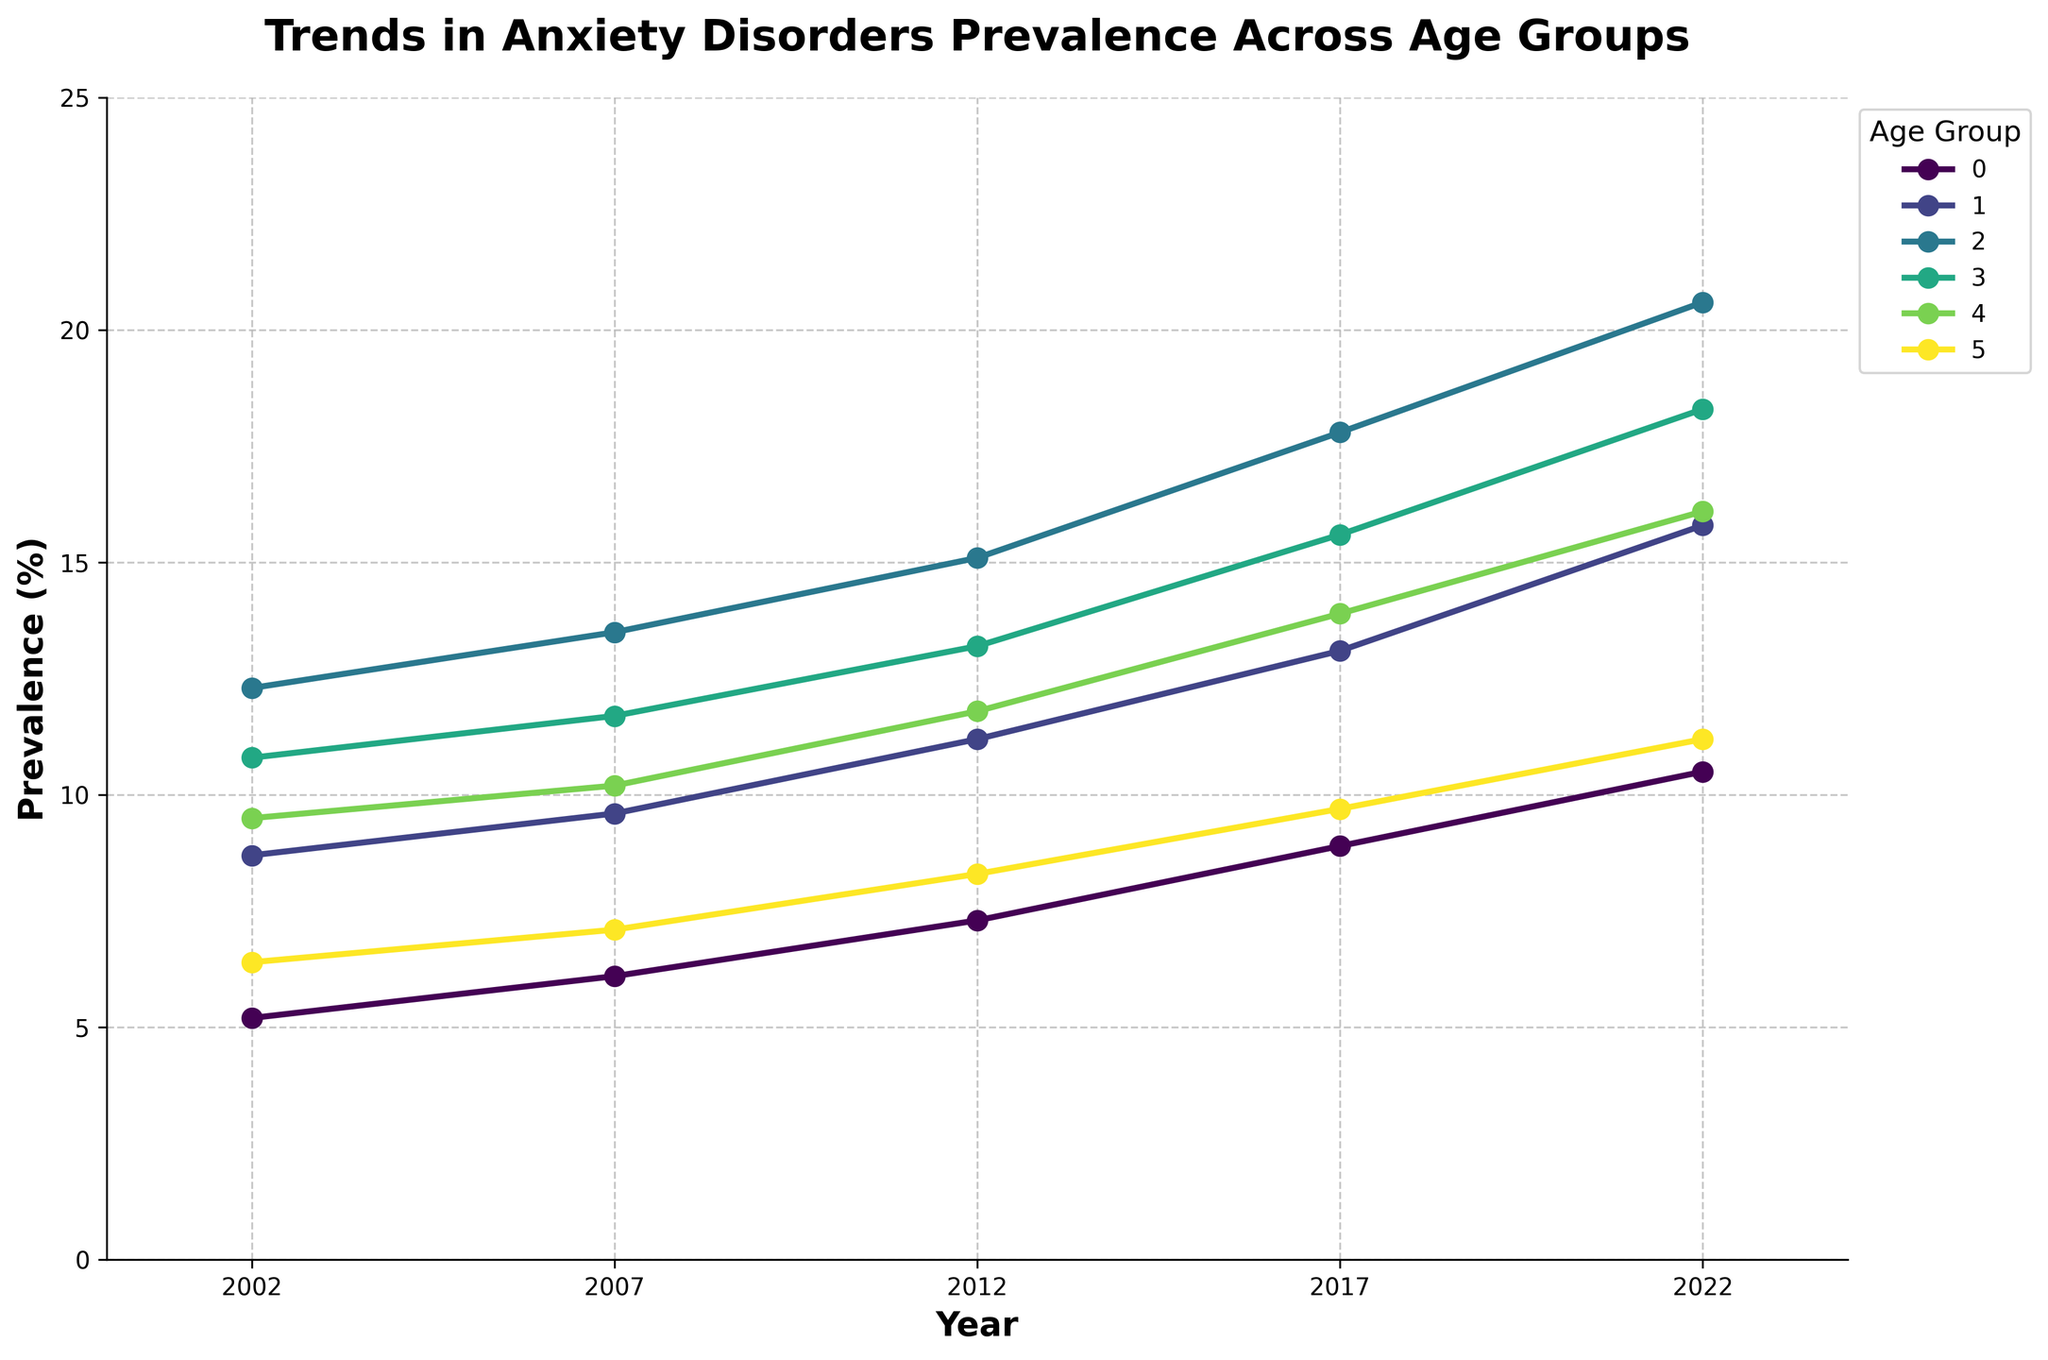Which age group had the highest prevalence of anxiety disorders in 2022? To find the answer, look at the data points for the year 2022 and identify which age group has the highest percentage. The Young Adults (18-25) have the highest prevalence at 20.6%.
Answer: Young Adults (18-25) Which age group showed the greatest increase in anxiety disorder prevalence from 2002 to 2022? Calculate the increase for each age group by subtracting the 2002 prevalence from the 2022 prevalence. The increase for Young Adults (18-25) is the highest, from 12.3% to 20.6%: 20.6 - 12.3 = 8.3%.
Answer: Young Adults (18-25) How did the prevalence of anxiety disorders in Adolescents (12-17) change from 2012 to 2017? Subtract the 2012 prevalence (11.2%) from the 2017 prevalence (13.1%): 13.1% - 11.2% = 1.9%.
Answer: Increased by 1.9% Which two age groups had the smallest difference in anxiety prevalence in 2007? Compare the 2007 data points for each age group pair. The smallest difference is between Adults (26-40) at 11.7% and Middle-aged Adults (41-60) at 10.2%: 11.7% - 10.2% = 1.5%.
Answer: Adults (26-40) and Middle-aged Adults (41-60) How does the prevalence trend for Older Adults (61+) compare visually to that of Children (5-11)? Visually check the slope of the lines representing Older Adults (61+) and Children (5-11). Both lines show an upward trend, but the slope for Children (5-11) is steeper, indicating a faster increase.
Answer: Steeper for Children (5-11) What is the average prevalence of anxiety disorders for Adults (26-40) over the 20 years? Sum the data points for Adults (26-40) across the years and divide by the number of years: (10.8 + 11.7 + 13.2 + 15.6 + 18.3)/5 = 13.92%.
Answer: 13.92% In which year did Middle-aged Adults (41-60) and Older Adults (61+) have the same prevalence increase compared to the previous recorded year? Compare the year-over-year increase for both groups. The same increase can be seen from 2007 to 2012 where both increased by 1.2% (Older Adults from 7.1% to 8.3% and Middle-aged Adults from 10.2% to 11.8%).
Answer: 2012 Which age group had the least variability in anxiety disorder prevalence over the past 20 years? To find the least variability, examine the range (maximum value - minimum value) for each age group. Older Adults (61+) showed the least variability with a range from 6.4% to 11.2% (11.2 - 6.4 = 4.8%).
Answer: Older Adults (61+) What visual pattern can you observe in the prevalence of anxiety disorders across all age groups over time? Observe the overall trend lines. Each age group's line shows a consistent increase in prevalence over the 20 years, indicating a rising trend in anxiety disorders across all age groups.
Answer: Consistent increase How much higher was the prevalence of anxiety disorders in Young Adults (18-25) compared to Children (5-11) in 2022? Subtract the 2022 prevalence for Children (5-11) from Young Adults (18-25). The difference is 20.6% - 10.5% = 10.1%.
Answer: 10.1% 